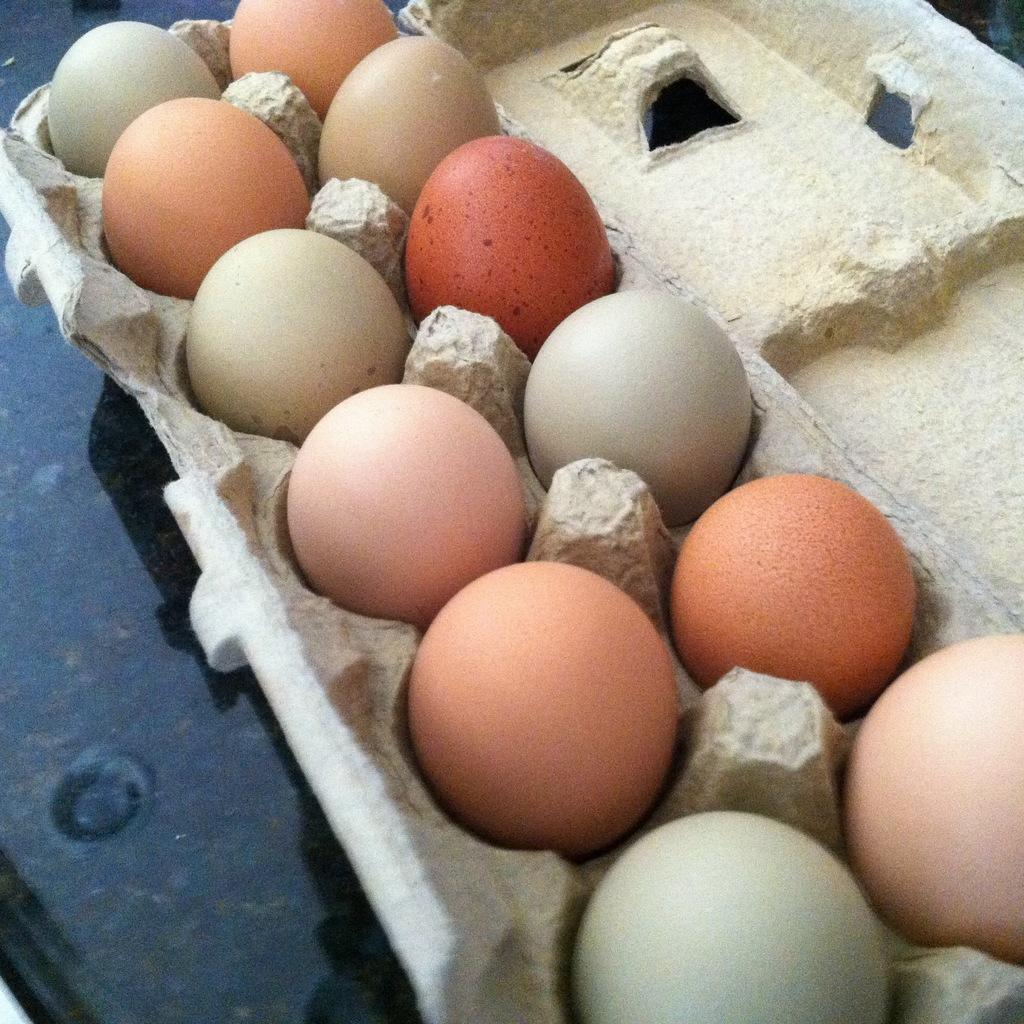What type of food item can be seen in the image? There are eggs in a tray in the image. What is the color of the surface at the bottom of the image? The surface at the bottom of the image is black. How do the eggs behave in the image? The eggs do not exhibit any behavior in the image, as they are stationary in the tray. 